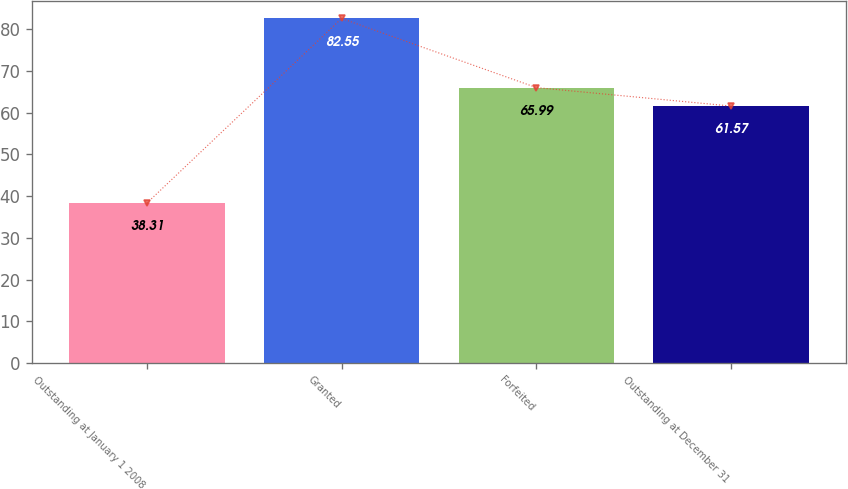Convert chart. <chart><loc_0><loc_0><loc_500><loc_500><bar_chart><fcel>Outstanding at January 1 2008<fcel>Granted<fcel>Forfeited<fcel>Outstanding at December 31<nl><fcel>38.31<fcel>82.55<fcel>65.99<fcel>61.57<nl></chart> 